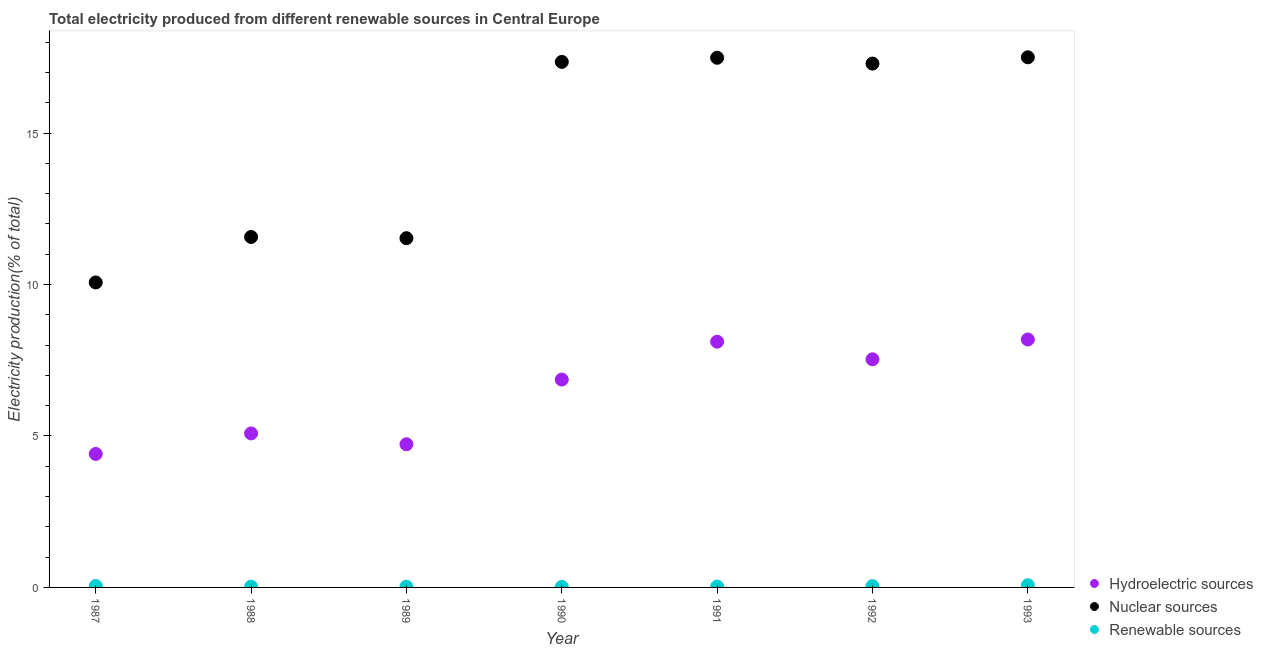What is the percentage of electricity produced by hydroelectric sources in 1991?
Provide a succinct answer. 8.11. Across all years, what is the maximum percentage of electricity produced by hydroelectric sources?
Your answer should be compact. 8.18. Across all years, what is the minimum percentage of electricity produced by hydroelectric sources?
Make the answer very short. 4.41. In which year was the percentage of electricity produced by hydroelectric sources maximum?
Provide a short and direct response. 1993. In which year was the percentage of electricity produced by nuclear sources minimum?
Provide a succinct answer. 1987. What is the total percentage of electricity produced by hydroelectric sources in the graph?
Your answer should be very brief. 44.9. What is the difference between the percentage of electricity produced by hydroelectric sources in 1988 and that in 1991?
Make the answer very short. -3.03. What is the difference between the percentage of electricity produced by hydroelectric sources in 1992 and the percentage of electricity produced by renewable sources in 1991?
Your answer should be compact. 7.5. What is the average percentage of electricity produced by nuclear sources per year?
Provide a succinct answer. 14.68. In the year 1989, what is the difference between the percentage of electricity produced by nuclear sources and percentage of electricity produced by renewable sources?
Keep it short and to the point. 11.5. In how many years, is the percentage of electricity produced by renewable sources greater than 10 %?
Keep it short and to the point. 0. What is the ratio of the percentage of electricity produced by nuclear sources in 1990 to that in 1992?
Your answer should be very brief. 1. What is the difference between the highest and the second highest percentage of electricity produced by hydroelectric sources?
Offer a very short reply. 0.07. What is the difference between the highest and the lowest percentage of electricity produced by nuclear sources?
Ensure brevity in your answer.  7.43. Is the percentage of electricity produced by hydroelectric sources strictly greater than the percentage of electricity produced by nuclear sources over the years?
Make the answer very short. No. Is the percentage of electricity produced by renewable sources strictly less than the percentage of electricity produced by hydroelectric sources over the years?
Your response must be concise. Yes. How many dotlines are there?
Offer a terse response. 3. How many legend labels are there?
Provide a short and direct response. 3. How are the legend labels stacked?
Ensure brevity in your answer.  Vertical. What is the title of the graph?
Your response must be concise. Total electricity produced from different renewable sources in Central Europe. Does "Taxes on goods and services" appear as one of the legend labels in the graph?
Your response must be concise. No. What is the label or title of the Y-axis?
Ensure brevity in your answer.  Electricity production(% of total). What is the Electricity production(% of total) in Hydroelectric sources in 1987?
Your answer should be compact. 4.41. What is the Electricity production(% of total) of Nuclear sources in 1987?
Offer a very short reply. 10.07. What is the Electricity production(% of total) in Renewable sources in 1987?
Offer a very short reply. 0.05. What is the Electricity production(% of total) in Hydroelectric sources in 1988?
Your answer should be very brief. 5.08. What is the Electricity production(% of total) of Nuclear sources in 1988?
Offer a terse response. 11.57. What is the Electricity production(% of total) of Renewable sources in 1988?
Offer a very short reply. 0.03. What is the Electricity production(% of total) of Hydroelectric sources in 1989?
Provide a short and direct response. 4.73. What is the Electricity production(% of total) in Nuclear sources in 1989?
Your answer should be very brief. 11.53. What is the Electricity production(% of total) in Renewable sources in 1989?
Your answer should be very brief. 0.02. What is the Electricity production(% of total) in Hydroelectric sources in 1990?
Your answer should be very brief. 6.86. What is the Electricity production(% of total) of Nuclear sources in 1990?
Your response must be concise. 17.35. What is the Electricity production(% of total) of Renewable sources in 1990?
Your answer should be compact. 0.02. What is the Electricity production(% of total) of Hydroelectric sources in 1991?
Your response must be concise. 8.11. What is the Electricity production(% of total) in Nuclear sources in 1991?
Make the answer very short. 17.48. What is the Electricity production(% of total) in Renewable sources in 1991?
Provide a short and direct response. 0.03. What is the Electricity production(% of total) in Hydroelectric sources in 1992?
Your answer should be very brief. 7.53. What is the Electricity production(% of total) of Nuclear sources in 1992?
Give a very brief answer. 17.29. What is the Electricity production(% of total) in Renewable sources in 1992?
Offer a very short reply. 0.04. What is the Electricity production(% of total) in Hydroelectric sources in 1993?
Your answer should be very brief. 8.18. What is the Electricity production(% of total) of Nuclear sources in 1993?
Give a very brief answer. 17.5. What is the Electricity production(% of total) of Renewable sources in 1993?
Provide a succinct answer. 0.07. Across all years, what is the maximum Electricity production(% of total) of Hydroelectric sources?
Your response must be concise. 8.18. Across all years, what is the maximum Electricity production(% of total) of Nuclear sources?
Your response must be concise. 17.5. Across all years, what is the maximum Electricity production(% of total) in Renewable sources?
Give a very brief answer. 0.07. Across all years, what is the minimum Electricity production(% of total) in Hydroelectric sources?
Ensure brevity in your answer.  4.41. Across all years, what is the minimum Electricity production(% of total) of Nuclear sources?
Your answer should be very brief. 10.07. Across all years, what is the minimum Electricity production(% of total) in Renewable sources?
Provide a succinct answer. 0.02. What is the total Electricity production(% of total) in Hydroelectric sources in the graph?
Provide a short and direct response. 44.9. What is the total Electricity production(% of total) of Nuclear sources in the graph?
Your response must be concise. 102.79. What is the total Electricity production(% of total) in Renewable sources in the graph?
Ensure brevity in your answer.  0.26. What is the difference between the Electricity production(% of total) of Hydroelectric sources in 1987 and that in 1988?
Offer a terse response. -0.68. What is the difference between the Electricity production(% of total) of Nuclear sources in 1987 and that in 1988?
Your answer should be very brief. -1.5. What is the difference between the Electricity production(% of total) in Renewable sources in 1987 and that in 1988?
Your response must be concise. 0.02. What is the difference between the Electricity production(% of total) in Hydroelectric sources in 1987 and that in 1989?
Your answer should be very brief. -0.32. What is the difference between the Electricity production(% of total) in Nuclear sources in 1987 and that in 1989?
Give a very brief answer. -1.46. What is the difference between the Electricity production(% of total) of Renewable sources in 1987 and that in 1989?
Ensure brevity in your answer.  0.02. What is the difference between the Electricity production(% of total) of Hydroelectric sources in 1987 and that in 1990?
Keep it short and to the point. -2.46. What is the difference between the Electricity production(% of total) of Nuclear sources in 1987 and that in 1990?
Offer a terse response. -7.28. What is the difference between the Electricity production(% of total) of Renewable sources in 1987 and that in 1990?
Offer a very short reply. 0.03. What is the difference between the Electricity production(% of total) in Hydroelectric sources in 1987 and that in 1991?
Your answer should be compact. -3.71. What is the difference between the Electricity production(% of total) of Nuclear sources in 1987 and that in 1991?
Ensure brevity in your answer.  -7.42. What is the difference between the Electricity production(% of total) of Renewable sources in 1987 and that in 1991?
Ensure brevity in your answer.  0.02. What is the difference between the Electricity production(% of total) in Hydroelectric sources in 1987 and that in 1992?
Make the answer very short. -3.12. What is the difference between the Electricity production(% of total) of Nuclear sources in 1987 and that in 1992?
Provide a short and direct response. -7.23. What is the difference between the Electricity production(% of total) of Renewable sources in 1987 and that in 1992?
Ensure brevity in your answer.  0.01. What is the difference between the Electricity production(% of total) in Hydroelectric sources in 1987 and that in 1993?
Keep it short and to the point. -3.78. What is the difference between the Electricity production(% of total) in Nuclear sources in 1987 and that in 1993?
Keep it short and to the point. -7.43. What is the difference between the Electricity production(% of total) of Renewable sources in 1987 and that in 1993?
Make the answer very short. -0.02. What is the difference between the Electricity production(% of total) in Hydroelectric sources in 1988 and that in 1989?
Keep it short and to the point. 0.36. What is the difference between the Electricity production(% of total) of Nuclear sources in 1988 and that in 1989?
Offer a terse response. 0.04. What is the difference between the Electricity production(% of total) of Renewable sources in 1988 and that in 1989?
Your response must be concise. 0. What is the difference between the Electricity production(% of total) in Hydroelectric sources in 1988 and that in 1990?
Ensure brevity in your answer.  -1.78. What is the difference between the Electricity production(% of total) of Nuclear sources in 1988 and that in 1990?
Provide a short and direct response. -5.78. What is the difference between the Electricity production(% of total) of Renewable sources in 1988 and that in 1990?
Your answer should be compact. 0.01. What is the difference between the Electricity production(% of total) of Hydroelectric sources in 1988 and that in 1991?
Provide a short and direct response. -3.03. What is the difference between the Electricity production(% of total) of Nuclear sources in 1988 and that in 1991?
Keep it short and to the point. -5.92. What is the difference between the Electricity production(% of total) in Renewable sources in 1988 and that in 1991?
Your response must be concise. -0. What is the difference between the Electricity production(% of total) of Hydroelectric sources in 1988 and that in 1992?
Provide a succinct answer. -2.45. What is the difference between the Electricity production(% of total) of Nuclear sources in 1988 and that in 1992?
Provide a short and direct response. -5.72. What is the difference between the Electricity production(% of total) of Renewable sources in 1988 and that in 1992?
Keep it short and to the point. -0.02. What is the difference between the Electricity production(% of total) of Hydroelectric sources in 1988 and that in 1993?
Keep it short and to the point. -3.1. What is the difference between the Electricity production(% of total) of Nuclear sources in 1988 and that in 1993?
Give a very brief answer. -5.93. What is the difference between the Electricity production(% of total) of Renewable sources in 1988 and that in 1993?
Provide a succinct answer. -0.05. What is the difference between the Electricity production(% of total) of Hydroelectric sources in 1989 and that in 1990?
Ensure brevity in your answer.  -2.14. What is the difference between the Electricity production(% of total) of Nuclear sources in 1989 and that in 1990?
Give a very brief answer. -5.82. What is the difference between the Electricity production(% of total) in Renewable sources in 1989 and that in 1990?
Provide a succinct answer. 0. What is the difference between the Electricity production(% of total) of Hydroelectric sources in 1989 and that in 1991?
Keep it short and to the point. -3.39. What is the difference between the Electricity production(% of total) in Nuclear sources in 1989 and that in 1991?
Provide a succinct answer. -5.96. What is the difference between the Electricity production(% of total) in Renewable sources in 1989 and that in 1991?
Your answer should be very brief. -0. What is the difference between the Electricity production(% of total) of Hydroelectric sources in 1989 and that in 1992?
Provide a succinct answer. -2.8. What is the difference between the Electricity production(% of total) in Nuclear sources in 1989 and that in 1992?
Offer a very short reply. -5.76. What is the difference between the Electricity production(% of total) of Renewable sources in 1989 and that in 1992?
Offer a very short reply. -0.02. What is the difference between the Electricity production(% of total) in Hydroelectric sources in 1989 and that in 1993?
Your answer should be compact. -3.46. What is the difference between the Electricity production(% of total) of Nuclear sources in 1989 and that in 1993?
Offer a very short reply. -5.97. What is the difference between the Electricity production(% of total) of Renewable sources in 1989 and that in 1993?
Offer a terse response. -0.05. What is the difference between the Electricity production(% of total) of Hydroelectric sources in 1990 and that in 1991?
Your answer should be very brief. -1.25. What is the difference between the Electricity production(% of total) of Nuclear sources in 1990 and that in 1991?
Offer a terse response. -0.14. What is the difference between the Electricity production(% of total) of Renewable sources in 1990 and that in 1991?
Keep it short and to the point. -0.01. What is the difference between the Electricity production(% of total) of Hydroelectric sources in 1990 and that in 1992?
Give a very brief answer. -0.67. What is the difference between the Electricity production(% of total) of Nuclear sources in 1990 and that in 1992?
Your response must be concise. 0.06. What is the difference between the Electricity production(% of total) of Renewable sources in 1990 and that in 1992?
Your answer should be very brief. -0.02. What is the difference between the Electricity production(% of total) in Hydroelectric sources in 1990 and that in 1993?
Keep it short and to the point. -1.32. What is the difference between the Electricity production(% of total) in Nuclear sources in 1990 and that in 1993?
Make the answer very short. -0.15. What is the difference between the Electricity production(% of total) of Renewable sources in 1990 and that in 1993?
Give a very brief answer. -0.05. What is the difference between the Electricity production(% of total) in Hydroelectric sources in 1991 and that in 1992?
Make the answer very short. 0.58. What is the difference between the Electricity production(% of total) in Nuclear sources in 1991 and that in 1992?
Give a very brief answer. 0.19. What is the difference between the Electricity production(% of total) in Renewable sources in 1991 and that in 1992?
Keep it short and to the point. -0.01. What is the difference between the Electricity production(% of total) in Hydroelectric sources in 1991 and that in 1993?
Provide a succinct answer. -0.07. What is the difference between the Electricity production(% of total) of Nuclear sources in 1991 and that in 1993?
Give a very brief answer. -0.02. What is the difference between the Electricity production(% of total) in Renewable sources in 1991 and that in 1993?
Give a very brief answer. -0.04. What is the difference between the Electricity production(% of total) of Hydroelectric sources in 1992 and that in 1993?
Your answer should be very brief. -0.65. What is the difference between the Electricity production(% of total) of Nuclear sources in 1992 and that in 1993?
Offer a terse response. -0.21. What is the difference between the Electricity production(% of total) of Renewable sources in 1992 and that in 1993?
Provide a short and direct response. -0.03. What is the difference between the Electricity production(% of total) in Hydroelectric sources in 1987 and the Electricity production(% of total) in Nuclear sources in 1988?
Make the answer very short. -7.16. What is the difference between the Electricity production(% of total) of Hydroelectric sources in 1987 and the Electricity production(% of total) of Renewable sources in 1988?
Provide a short and direct response. 4.38. What is the difference between the Electricity production(% of total) in Nuclear sources in 1987 and the Electricity production(% of total) in Renewable sources in 1988?
Provide a succinct answer. 10.04. What is the difference between the Electricity production(% of total) of Hydroelectric sources in 1987 and the Electricity production(% of total) of Nuclear sources in 1989?
Provide a succinct answer. -7.12. What is the difference between the Electricity production(% of total) of Hydroelectric sources in 1987 and the Electricity production(% of total) of Renewable sources in 1989?
Ensure brevity in your answer.  4.38. What is the difference between the Electricity production(% of total) of Nuclear sources in 1987 and the Electricity production(% of total) of Renewable sources in 1989?
Offer a very short reply. 10.04. What is the difference between the Electricity production(% of total) in Hydroelectric sources in 1987 and the Electricity production(% of total) in Nuclear sources in 1990?
Provide a short and direct response. -12.94. What is the difference between the Electricity production(% of total) of Hydroelectric sources in 1987 and the Electricity production(% of total) of Renewable sources in 1990?
Your answer should be compact. 4.39. What is the difference between the Electricity production(% of total) in Nuclear sources in 1987 and the Electricity production(% of total) in Renewable sources in 1990?
Give a very brief answer. 10.05. What is the difference between the Electricity production(% of total) of Hydroelectric sources in 1987 and the Electricity production(% of total) of Nuclear sources in 1991?
Keep it short and to the point. -13.08. What is the difference between the Electricity production(% of total) in Hydroelectric sources in 1987 and the Electricity production(% of total) in Renewable sources in 1991?
Make the answer very short. 4.38. What is the difference between the Electricity production(% of total) in Nuclear sources in 1987 and the Electricity production(% of total) in Renewable sources in 1991?
Keep it short and to the point. 10.04. What is the difference between the Electricity production(% of total) of Hydroelectric sources in 1987 and the Electricity production(% of total) of Nuclear sources in 1992?
Offer a very short reply. -12.89. What is the difference between the Electricity production(% of total) of Hydroelectric sources in 1987 and the Electricity production(% of total) of Renewable sources in 1992?
Provide a short and direct response. 4.36. What is the difference between the Electricity production(% of total) in Nuclear sources in 1987 and the Electricity production(% of total) in Renewable sources in 1992?
Keep it short and to the point. 10.02. What is the difference between the Electricity production(% of total) in Hydroelectric sources in 1987 and the Electricity production(% of total) in Nuclear sources in 1993?
Your answer should be very brief. -13.09. What is the difference between the Electricity production(% of total) of Hydroelectric sources in 1987 and the Electricity production(% of total) of Renewable sources in 1993?
Provide a succinct answer. 4.33. What is the difference between the Electricity production(% of total) of Nuclear sources in 1987 and the Electricity production(% of total) of Renewable sources in 1993?
Provide a succinct answer. 9.99. What is the difference between the Electricity production(% of total) in Hydroelectric sources in 1988 and the Electricity production(% of total) in Nuclear sources in 1989?
Your response must be concise. -6.44. What is the difference between the Electricity production(% of total) in Hydroelectric sources in 1988 and the Electricity production(% of total) in Renewable sources in 1989?
Your response must be concise. 5.06. What is the difference between the Electricity production(% of total) of Nuclear sources in 1988 and the Electricity production(% of total) of Renewable sources in 1989?
Keep it short and to the point. 11.55. What is the difference between the Electricity production(% of total) of Hydroelectric sources in 1988 and the Electricity production(% of total) of Nuclear sources in 1990?
Provide a short and direct response. -12.26. What is the difference between the Electricity production(% of total) in Hydroelectric sources in 1988 and the Electricity production(% of total) in Renewable sources in 1990?
Your answer should be very brief. 5.06. What is the difference between the Electricity production(% of total) in Nuclear sources in 1988 and the Electricity production(% of total) in Renewable sources in 1990?
Provide a short and direct response. 11.55. What is the difference between the Electricity production(% of total) of Hydroelectric sources in 1988 and the Electricity production(% of total) of Nuclear sources in 1991?
Your answer should be very brief. -12.4. What is the difference between the Electricity production(% of total) of Hydroelectric sources in 1988 and the Electricity production(% of total) of Renewable sources in 1991?
Provide a short and direct response. 5.06. What is the difference between the Electricity production(% of total) of Nuclear sources in 1988 and the Electricity production(% of total) of Renewable sources in 1991?
Give a very brief answer. 11.54. What is the difference between the Electricity production(% of total) in Hydroelectric sources in 1988 and the Electricity production(% of total) in Nuclear sources in 1992?
Keep it short and to the point. -12.21. What is the difference between the Electricity production(% of total) of Hydroelectric sources in 1988 and the Electricity production(% of total) of Renewable sources in 1992?
Offer a very short reply. 5.04. What is the difference between the Electricity production(% of total) in Nuclear sources in 1988 and the Electricity production(% of total) in Renewable sources in 1992?
Provide a short and direct response. 11.53. What is the difference between the Electricity production(% of total) of Hydroelectric sources in 1988 and the Electricity production(% of total) of Nuclear sources in 1993?
Keep it short and to the point. -12.42. What is the difference between the Electricity production(% of total) of Hydroelectric sources in 1988 and the Electricity production(% of total) of Renewable sources in 1993?
Provide a succinct answer. 5.01. What is the difference between the Electricity production(% of total) in Nuclear sources in 1988 and the Electricity production(% of total) in Renewable sources in 1993?
Provide a short and direct response. 11.5. What is the difference between the Electricity production(% of total) in Hydroelectric sources in 1989 and the Electricity production(% of total) in Nuclear sources in 1990?
Give a very brief answer. -12.62. What is the difference between the Electricity production(% of total) in Hydroelectric sources in 1989 and the Electricity production(% of total) in Renewable sources in 1990?
Provide a short and direct response. 4.71. What is the difference between the Electricity production(% of total) in Nuclear sources in 1989 and the Electricity production(% of total) in Renewable sources in 1990?
Keep it short and to the point. 11.51. What is the difference between the Electricity production(% of total) of Hydroelectric sources in 1989 and the Electricity production(% of total) of Nuclear sources in 1991?
Make the answer very short. -12.76. What is the difference between the Electricity production(% of total) of Hydroelectric sources in 1989 and the Electricity production(% of total) of Renewable sources in 1991?
Provide a succinct answer. 4.7. What is the difference between the Electricity production(% of total) of Hydroelectric sources in 1989 and the Electricity production(% of total) of Nuclear sources in 1992?
Make the answer very short. -12.57. What is the difference between the Electricity production(% of total) in Hydroelectric sources in 1989 and the Electricity production(% of total) in Renewable sources in 1992?
Your answer should be very brief. 4.68. What is the difference between the Electricity production(% of total) of Nuclear sources in 1989 and the Electricity production(% of total) of Renewable sources in 1992?
Provide a short and direct response. 11.49. What is the difference between the Electricity production(% of total) in Hydroelectric sources in 1989 and the Electricity production(% of total) in Nuclear sources in 1993?
Ensure brevity in your answer.  -12.77. What is the difference between the Electricity production(% of total) in Hydroelectric sources in 1989 and the Electricity production(% of total) in Renewable sources in 1993?
Provide a succinct answer. 4.65. What is the difference between the Electricity production(% of total) of Nuclear sources in 1989 and the Electricity production(% of total) of Renewable sources in 1993?
Provide a succinct answer. 11.46. What is the difference between the Electricity production(% of total) of Hydroelectric sources in 1990 and the Electricity production(% of total) of Nuclear sources in 1991?
Provide a succinct answer. -10.62. What is the difference between the Electricity production(% of total) of Hydroelectric sources in 1990 and the Electricity production(% of total) of Renewable sources in 1991?
Your response must be concise. 6.83. What is the difference between the Electricity production(% of total) in Nuclear sources in 1990 and the Electricity production(% of total) in Renewable sources in 1991?
Keep it short and to the point. 17.32. What is the difference between the Electricity production(% of total) of Hydroelectric sources in 1990 and the Electricity production(% of total) of Nuclear sources in 1992?
Offer a terse response. -10.43. What is the difference between the Electricity production(% of total) of Hydroelectric sources in 1990 and the Electricity production(% of total) of Renewable sources in 1992?
Your answer should be very brief. 6.82. What is the difference between the Electricity production(% of total) of Nuclear sources in 1990 and the Electricity production(% of total) of Renewable sources in 1992?
Make the answer very short. 17.31. What is the difference between the Electricity production(% of total) of Hydroelectric sources in 1990 and the Electricity production(% of total) of Nuclear sources in 1993?
Keep it short and to the point. -10.64. What is the difference between the Electricity production(% of total) in Hydroelectric sources in 1990 and the Electricity production(% of total) in Renewable sources in 1993?
Offer a very short reply. 6.79. What is the difference between the Electricity production(% of total) of Nuclear sources in 1990 and the Electricity production(% of total) of Renewable sources in 1993?
Provide a succinct answer. 17.28. What is the difference between the Electricity production(% of total) of Hydroelectric sources in 1991 and the Electricity production(% of total) of Nuclear sources in 1992?
Ensure brevity in your answer.  -9.18. What is the difference between the Electricity production(% of total) of Hydroelectric sources in 1991 and the Electricity production(% of total) of Renewable sources in 1992?
Provide a succinct answer. 8.07. What is the difference between the Electricity production(% of total) of Nuclear sources in 1991 and the Electricity production(% of total) of Renewable sources in 1992?
Offer a terse response. 17.44. What is the difference between the Electricity production(% of total) of Hydroelectric sources in 1991 and the Electricity production(% of total) of Nuclear sources in 1993?
Offer a terse response. -9.39. What is the difference between the Electricity production(% of total) in Hydroelectric sources in 1991 and the Electricity production(% of total) in Renewable sources in 1993?
Your answer should be compact. 8.04. What is the difference between the Electricity production(% of total) in Nuclear sources in 1991 and the Electricity production(% of total) in Renewable sources in 1993?
Your answer should be compact. 17.41. What is the difference between the Electricity production(% of total) in Hydroelectric sources in 1992 and the Electricity production(% of total) in Nuclear sources in 1993?
Offer a terse response. -9.97. What is the difference between the Electricity production(% of total) of Hydroelectric sources in 1992 and the Electricity production(% of total) of Renewable sources in 1993?
Keep it short and to the point. 7.46. What is the difference between the Electricity production(% of total) in Nuclear sources in 1992 and the Electricity production(% of total) in Renewable sources in 1993?
Offer a very short reply. 17.22. What is the average Electricity production(% of total) in Hydroelectric sources per year?
Ensure brevity in your answer.  6.41. What is the average Electricity production(% of total) in Nuclear sources per year?
Keep it short and to the point. 14.68. What is the average Electricity production(% of total) of Renewable sources per year?
Make the answer very short. 0.04. In the year 1987, what is the difference between the Electricity production(% of total) in Hydroelectric sources and Electricity production(% of total) in Nuclear sources?
Offer a very short reply. -5.66. In the year 1987, what is the difference between the Electricity production(% of total) in Hydroelectric sources and Electricity production(% of total) in Renewable sources?
Offer a very short reply. 4.36. In the year 1987, what is the difference between the Electricity production(% of total) in Nuclear sources and Electricity production(% of total) in Renewable sources?
Your answer should be very brief. 10.02. In the year 1988, what is the difference between the Electricity production(% of total) of Hydroelectric sources and Electricity production(% of total) of Nuclear sources?
Your response must be concise. -6.48. In the year 1988, what is the difference between the Electricity production(% of total) in Hydroelectric sources and Electricity production(% of total) in Renewable sources?
Your answer should be very brief. 5.06. In the year 1988, what is the difference between the Electricity production(% of total) in Nuclear sources and Electricity production(% of total) in Renewable sources?
Make the answer very short. 11.54. In the year 1989, what is the difference between the Electricity production(% of total) in Hydroelectric sources and Electricity production(% of total) in Nuclear sources?
Make the answer very short. -6.8. In the year 1989, what is the difference between the Electricity production(% of total) of Hydroelectric sources and Electricity production(% of total) of Renewable sources?
Your answer should be compact. 4.7. In the year 1989, what is the difference between the Electricity production(% of total) of Nuclear sources and Electricity production(% of total) of Renewable sources?
Provide a short and direct response. 11.5. In the year 1990, what is the difference between the Electricity production(% of total) of Hydroelectric sources and Electricity production(% of total) of Nuclear sources?
Offer a very short reply. -10.49. In the year 1990, what is the difference between the Electricity production(% of total) in Hydroelectric sources and Electricity production(% of total) in Renewable sources?
Give a very brief answer. 6.84. In the year 1990, what is the difference between the Electricity production(% of total) of Nuclear sources and Electricity production(% of total) of Renewable sources?
Keep it short and to the point. 17.33. In the year 1991, what is the difference between the Electricity production(% of total) of Hydroelectric sources and Electricity production(% of total) of Nuclear sources?
Make the answer very short. -9.37. In the year 1991, what is the difference between the Electricity production(% of total) of Hydroelectric sources and Electricity production(% of total) of Renewable sources?
Make the answer very short. 8.08. In the year 1991, what is the difference between the Electricity production(% of total) in Nuclear sources and Electricity production(% of total) in Renewable sources?
Your answer should be compact. 17.46. In the year 1992, what is the difference between the Electricity production(% of total) in Hydroelectric sources and Electricity production(% of total) in Nuclear sources?
Give a very brief answer. -9.76. In the year 1992, what is the difference between the Electricity production(% of total) of Hydroelectric sources and Electricity production(% of total) of Renewable sources?
Ensure brevity in your answer.  7.49. In the year 1992, what is the difference between the Electricity production(% of total) in Nuclear sources and Electricity production(% of total) in Renewable sources?
Keep it short and to the point. 17.25. In the year 1993, what is the difference between the Electricity production(% of total) in Hydroelectric sources and Electricity production(% of total) in Nuclear sources?
Your answer should be very brief. -9.31. In the year 1993, what is the difference between the Electricity production(% of total) of Hydroelectric sources and Electricity production(% of total) of Renewable sources?
Your answer should be very brief. 8.11. In the year 1993, what is the difference between the Electricity production(% of total) of Nuclear sources and Electricity production(% of total) of Renewable sources?
Ensure brevity in your answer.  17.43. What is the ratio of the Electricity production(% of total) in Hydroelectric sources in 1987 to that in 1988?
Provide a succinct answer. 0.87. What is the ratio of the Electricity production(% of total) in Nuclear sources in 1987 to that in 1988?
Offer a very short reply. 0.87. What is the ratio of the Electricity production(% of total) in Renewable sources in 1987 to that in 1988?
Your answer should be compact. 1.87. What is the ratio of the Electricity production(% of total) in Hydroelectric sources in 1987 to that in 1989?
Offer a very short reply. 0.93. What is the ratio of the Electricity production(% of total) in Nuclear sources in 1987 to that in 1989?
Your answer should be very brief. 0.87. What is the ratio of the Electricity production(% of total) in Renewable sources in 1987 to that in 1989?
Ensure brevity in your answer.  2.05. What is the ratio of the Electricity production(% of total) in Hydroelectric sources in 1987 to that in 1990?
Provide a short and direct response. 0.64. What is the ratio of the Electricity production(% of total) in Nuclear sources in 1987 to that in 1990?
Ensure brevity in your answer.  0.58. What is the ratio of the Electricity production(% of total) of Renewable sources in 1987 to that in 1990?
Your answer should be very brief. 2.47. What is the ratio of the Electricity production(% of total) in Hydroelectric sources in 1987 to that in 1991?
Provide a succinct answer. 0.54. What is the ratio of the Electricity production(% of total) in Nuclear sources in 1987 to that in 1991?
Make the answer very short. 0.58. What is the ratio of the Electricity production(% of total) of Renewable sources in 1987 to that in 1991?
Offer a terse response. 1.69. What is the ratio of the Electricity production(% of total) in Hydroelectric sources in 1987 to that in 1992?
Keep it short and to the point. 0.59. What is the ratio of the Electricity production(% of total) in Nuclear sources in 1987 to that in 1992?
Offer a terse response. 0.58. What is the ratio of the Electricity production(% of total) of Renewable sources in 1987 to that in 1992?
Your answer should be compact. 1.13. What is the ratio of the Electricity production(% of total) of Hydroelectric sources in 1987 to that in 1993?
Ensure brevity in your answer.  0.54. What is the ratio of the Electricity production(% of total) in Nuclear sources in 1987 to that in 1993?
Give a very brief answer. 0.58. What is the ratio of the Electricity production(% of total) of Renewable sources in 1987 to that in 1993?
Offer a terse response. 0.66. What is the ratio of the Electricity production(% of total) of Hydroelectric sources in 1988 to that in 1989?
Ensure brevity in your answer.  1.08. What is the ratio of the Electricity production(% of total) of Nuclear sources in 1988 to that in 1989?
Keep it short and to the point. 1. What is the ratio of the Electricity production(% of total) in Renewable sources in 1988 to that in 1989?
Make the answer very short. 1.09. What is the ratio of the Electricity production(% of total) in Hydroelectric sources in 1988 to that in 1990?
Give a very brief answer. 0.74. What is the ratio of the Electricity production(% of total) of Nuclear sources in 1988 to that in 1990?
Ensure brevity in your answer.  0.67. What is the ratio of the Electricity production(% of total) of Renewable sources in 1988 to that in 1990?
Ensure brevity in your answer.  1.32. What is the ratio of the Electricity production(% of total) in Hydroelectric sources in 1988 to that in 1991?
Keep it short and to the point. 0.63. What is the ratio of the Electricity production(% of total) in Nuclear sources in 1988 to that in 1991?
Your response must be concise. 0.66. What is the ratio of the Electricity production(% of total) in Renewable sources in 1988 to that in 1991?
Your response must be concise. 0.9. What is the ratio of the Electricity production(% of total) of Hydroelectric sources in 1988 to that in 1992?
Make the answer very short. 0.68. What is the ratio of the Electricity production(% of total) in Nuclear sources in 1988 to that in 1992?
Your answer should be compact. 0.67. What is the ratio of the Electricity production(% of total) of Renewable sources in 1988 to that in 1992?
Offer a terse response. 0.6. What is the ratio of the Electricity production(% of total) in Hydroelectric sources in 1988 to that in 1993?
Provide a succinct answer. 0.62. What is the ratio of the Electricity production(% of total) in Nuclear sources in 1988 to that in 1993?
Ensure brevity in your answer.  0.66. What is the ratio of the Electricity production(% of total) in Renewable sources in 1988 to that in 1993?
Your answer should be very brief. 0.35. What is the ratio of the Electricity production(% of total) in Hydroelectric sources in 1989 to that in 1990?
Offer a very short reply. 0.69. What is the ratio of the Electricity production(% of total) in Nuclear sources in 1989 to that in 1990?
Ensure brevity in your answer.  0.66. What is the ratio of the Electricity production(% of total) of Renewable sources in 1989 to that in 1990?
Make the answer very short. 1.21. What is the ratio of the Electricity production(% of total) in Hydroelectric sources in 1989 to that in 1991?
Ensure brevity in your answer.  0.58. What is the ratio of the Electricity production(% of total) of Nuclear sources in 1989 to that in 1991?
Ensure brevity in your answer.  0.66. What is the ratio of the Electricity production(% of total) of Renewable sources in 1989 to that in 1991?
Make the answer very short. 0.83. What is the ratio of the Electricity production(% of total) in Hydroelectric sources in 1989 to that in 1992?
Provide a short and direct response. 0.63. What is the ratio of the Electricity production(% of total) in Renewable sources in 1989 to that in 1992?
Your answer should be compact. 0.55. What is the ratio of the Electricity production(% of total) of Hydroelectric sources in 1989 to that in 1993?
Give a very brief answer. 0.58. What is the ratio of the Electricity production(% of total) of Nuclear sources in 1989 to that in 1993?
Offer a very short reply. 0.66. What is the ratio of the Electricity production(% of total) in Renewable sources in 1989 to that in 1993?
Make the answer very short. 0.32. What is the ratio of the Electricity production(% of total) in Hydroelectric sources in 1990 to that in 1991?
Your response must be concise. 0.85. What is the ratio of the Electricity production(% of total) of Nuclear sources in 1990 to that in 1991?
Offer a very short reply. 0.99. What is the ratio of the Electricity production(% of total) in Renewable sources in 1990 to that in 1991?
Provide a succinct answer. 0.69. What is the ratio of the Electricity production(% of total) in Hydroelectric sources in 1990 to that in 1992?
Provide a short and direct response. 0.91. What is the ratio of the Electricity production(% of total) of Nuclear sources in 1990 to that in 1992?
Make the answer very short. 1. What is the ratio of the Electricity production(% of total) in Renewable sources in 1990 to that in 1992?
Your answer should be very brief. 0.46. What is the ratio of the Electricity production(% of total) in Hydroelectric sources in 1990 to that in 1993?
Your answer should be compact. 0.84. What is the ratio of the Electricity production(% of total) of Renewable sources in 1990 to that in 1993?
Give a very brief answer. 0.27. What is the ratio of the Electricity production(% of total) in Hydroelectric sources in 1991 to that in 1992?
Provide a succinct answer. 1.08. What is the ratio of the Electricity production(% of total) in Nuclear sources in 1991 to that in 1992?
Keep it short and to the point. 1.01. What is the ratio of the Electricity production(% of total) of Renewable sources in 1991 to that in 1992?
Your answer should be very brief. 0.67. What is the ratio of the Electricity production(% of total) of Renewable sources in 1991 to that in 1993?
Your answer should be very brief. 0.39. What is the ratio of the Electricity production(% of total) of Hydroelectric sources in 1992 to that in 1993?
Provide a short and direct response. 0.92. What is the ratio of the Electricity production(% of total) in Renewable sources in 1992 to that in 1993?
Your answer should be compact. 0.59. What is the difference between the highest and the second highest Electricity production(% of total) of Hydroelectric sources?
Ensure brevity in your answer.  0.07. What is the difference between the highest and the second highest Electricity production(% of total) in Nuclear sources?
Your answer should be compact. 0.02. What is the difference between the highest and the second highest Electricity production(% of total) of Renewable sources?
Give a very brief answer. 0.02. What is the difference between the highest and the lowest Electricity production(% of total) in Hydroelectric sources?
Provide a succinct answer. 3.78. What is the difference between the highest and the lowest Electricity production(% of total) of Nuclear sources?
Provide a short and direct response. 7.43. What is the difference between the highest and the lowest Electricity production(% of total) of Renewable sources?
Provide a succinct answer. 0.05. 